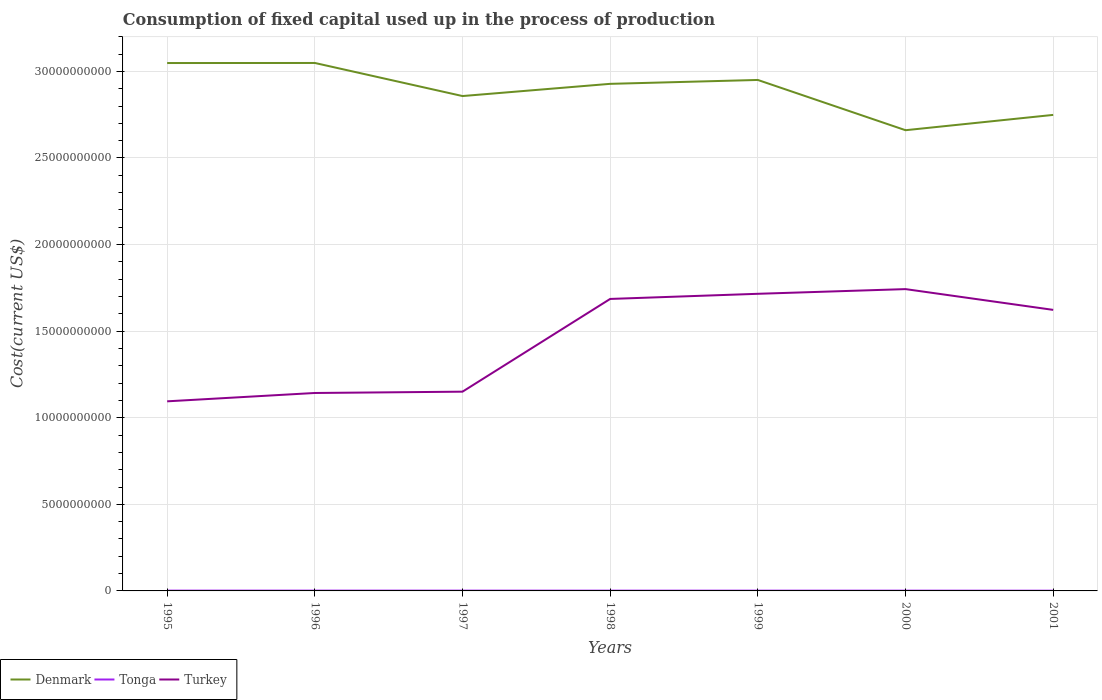How many different coloured lines are there?
Your answer should be compact. 3. Across all years, what is the maximum amount consumed in the process of production in Turkey?
Your answer should be very brief. 1.09e+1. In which year was the amount consumed in the process of production in Tonga maximum?
Offer a terse response. 2001. What is the total amount consumed in the process of production in Turkey in the graph?
Offer a terse response. -6.00e+09. What is the difference between the highest and the second highest amount consumed in the process of production in Denmark?
Your response must be concise. 3.88e+09. What is the difference between the highest and the lowest amount consumed in the process of production in Turkey?
Offer a very short reply. 4. How many years are there in the graph?
Your answer should be very brief. 7. Are the values on the major ticks of Y-axis written in scientific E-notation?
Your answer should be compact. No. Does the graph contain grids?
Provide a short and direct response. Yes. Where does the legend appear in the graph?
Your answer should be compact. Bottom left. How many legend labels are there?
Offer a terse response. 3. How are the legend labels stacked?
Ensure brevity in your answer.  Horizontal. What is the title of the graph?
Offer a terse response. Consumption of fixed capital used up in the process of production. Does "Togo" appear as one of the legend labels in the graph?
Your answer should be compact. No. What is the label or title of the Y-axis?
Ensure brevity in your answer.  Cost(current US$). What is the Cost(current US$) in Denmark in 1995?
Keep it short and to the point. 3.05e+1. What is the Cost(current US$) of Tonga in 1995?
Offer a very short reply. 1.70e+07. What is the Cost(current US$) in Turkey in 1995?
Offer a very short reply. 1.09e+1. What is the Cost(current US$) in Denmark in 1996?
Your response must be concise. 3.05e+1. What is the Cost(current US$) in Tonga in 1996?
Keep it short and to the point. 1.83e+07. What is the Cost(current US$) in Turkey in 1996?
Provide a succinct answer. 1.14e+1. What is the Cost(current US$) of Denmark in 1997?
Your answer should be very brief. 2.86e+1. What is the Cost(current US$) of Tonga in 1997?
Offer a very short reply. 1.72e+07. What is the Cost(current US$) in Turkey in 1997?
Give a very brief answer. 1.15e+1. What is the Cost(current US$) in Denmark in 1998?
Offer a terse response. 2.93e+1. What is the Cost(current US$) of Tonga in 1998?
Offer a terse response. 1.61e+07. What is the Cost(current US$) in Turkey in 1998?
Provide a short and direct response. 1.69e+1. What is the Cost(current US$) in Denmark in 1999?
Offer a very short reply. 2.95e+1. What is the Cost(current US$) in Tonga in 1999?
Your answer should be compact. 1.65e+07. What is the Cost(current US$) in Turkey in 1999?
Offer a terse response. 1.72e+1. What is the Cost(current US$) of Denmark in 2000?
Offer a very short reply. 2.66e+1. What is the Cost(current US$) in Tonga in 2000?
Your answer should be compact. 1.59e+07. What is the Cost(current US$) of Turkey in 2000?
Offer a very short reply. 1.74e+1. What is the Cost(current US$) of Denmark in 2001?
Make the answer very short. 2.75e+1. What is the Cost(current US$) of Tonga in 2001?
Offer a terse response. 1.39e+07. What is the Cost(current US$) of Turkey in 2001?
Keep it short and to the point. 1.62e+1. Across all years, what is the maximum Cost(current US$) of Denmark?
Give a very brief answer. 3.05e+1. Across all years, what is the maximum Cost(current US$) in Tonga?
Make the answer very short. 1.83e+07. Across all years, what is the maximum Cost(current US$) in Turkey?
Keep it short and to the point. 1.74e+1. Across all years, what is the minimum Cost(current US$) in Denmark?
Provide a succinct answer. 2.66e+1. Across all years, what is the minimum Cost(current US$) of Tonga?
Your answer should be very brief. 1.39e+07. Across all years, what is the minimum Cost(current US$) in Turkey?
Provide a succinct answer. 1.09e+1. What is the total Cost(current US$) of Denmark in the graph?
Provide a short and direct response. 2.02e+11. What is the total Cost(current US$) in Tonga in the graph?
Keep it short and to the point. 1.15e+08. What is the total Cost(current US$) of Turkey in the graph?
Ensure brevity in your answer.  1.02e+11. What is the difference between the Cost(current US$) of Denmark in 1995 and that in 1996?
Make the answer very short. -4.43e+06. What is the difference between the Cost(current US$) of Tonga in 1995 and that in 1996?
Make the answer very short. -1.26e+06. What is the difference between the Cost(current US$) in Turkey in 1995 and that in 1996?
Your response must be concise. -4.82e+08. What is the difference between the Cost(current US$) in Denmark in 1995 and that in 1997?
Keep it short and to the point. 1.91e+09. What is the difference between the Cost(current US$) of Tonga in 1995 and that in 1997?
Provide a short and direct response. -1.65e+05. What is the difference between the Cost(current US$) in Turkey in 1995 and that in 1997?
Offer a terse response. -5.57e+08. What is the difference between the Cost(current US$) in Denmark in 1995 and that in 1998?
Your answer should be compact. 1.20e+09. What is the difference between the Cost(current US$) in Tonga in 1995 and that in 1998?
Offer a terse response. 9.78e+05. What is the difference between the Cost(current US$) in Turkey in 1995 and that in 1998?
Keep it short and to the point. -5.91e+09. What is the difference between the Cost(current US$) in Denmark in 1995 and that in 1999?
Make the answer very short. 9.77e+08. What is the difference between the Cost(current US$) in Tonga in 1995 and that in 1999?
Ensure brevity in your answer.  5.65e+05. What is the difference between the Cost(current US$) in Turkey in 1995 and that in 1999?
Make the answer very short. -6.21e+09. What is the difference between the Cost(current US$) in Denmark in 1995 and that in 2000?
Your response must be concise. 3.88e+09. What is the difference between the Cost(current US$) of Tonga in 1995 and that in 2000?
Your answer should be very brief. 1.09e+06. What is the difference between the Cost(current US$) of Turkey in 1995 and that in 2000?
Your response must be concise. -6.48e+09. What is the difference between the Cost(current US$) in Denmark in 1995 and that in 2001?
Give a very brief answer. 2.99e+09. What is the difference between the Cost(current US$) of Tonga in 1995 and that in 2001?
Your answer should be compact. 3.12e+06. What is the difference between the Cost(current US$) in Turkey in 1995 and that in 2001?
Give a very brief answer. -5.28e+09. What is the difference between the Cost(current US$) of Denmark in 1996 and that in 1997?
Keep it short and to the point. 1.91e+09. What is the difference between the Cost(current US$) in Tonga in 1996 and that in 1997?
Your response must be concise. 1.10e+06. What is the difference between the Cost(current US$) of Turkey in 1996 and that in 1997?
Keep it short and to the point. -7.52e+07. What is the difference between the Cost(current US$) of Denmark in 1996 and that in 1998?
Provide a short and direct response. 1.21e+09. What is the difference between the Cost(current US$) of Tonga in 1996 and that in 1998?
Your answer should be very brief. 2.24e+06. What is the difference between the Cost(current US$) in Turkey in 1996 and that in 1998?
Your response must be concise. -5.43e+09. What is the difference between the Cost(current US$) in Denmark in 1996 and that in 1999?
Your answer should be very brief. 9.82e+08. What is the difference between the Cost(current US$) in Tonga in 1996 and that in 1999?
Keep it short and to the point. 1.83e+06. What is the difference between the Cost(current US$) of Turkey in 1996 and that in 1999?
Keep it short and to the point. -5.73e+09. What is the difference between the Cost(current US$) in Denmark in 1996 and that in 2000?
Provide a succinct answer. 3.88e+09. What is the difference between the Cost(current US$) of Tonga in 1996 and that in 2000?
Your answer should be compact. 2.35e+06. What is the difference between the Cost(current US$) in Turkey in 1996 and that in 2000?
Offer a very short reply. -6.00e+09. What is the difference between the Cost(current US$) in Denmark in 1996 and that in 2001?
Keep it short and to the point. 3.00e+09. What is the difference between the Cost(current US$) of Tonga in 1996 and that in 2001?
Make the answer very short. 4.38e+06. What is the difference between the Cost(current US$) in Turkey in 1996 and that in 2001?
Provide a short and direct response. -4.80e+09. What is the difference between the Cost(current US$) in Denmark in 1997 and that in 1998?
Offer a terse response. -7.05e+08. What is the difference between the Cost(current US$) in Tonga in 1997 and that in 1998?
Provide a short and direct response. 1.14e+06. What is the difference between the Cost(current US$) of Turkey in 1997 and that in 1998?
Give a very brief answer. -5.36e+09. What is the difference between the Cost(current US$) of Denmark in 1997 and that in 1999?
Ensure brevity in your answer.  -9.29e+08. What is the difference between the Cost(current US$) of Tonga in 1997 and that in 1999?
Provide a succinct answer. 7.30e+05. What is the difference between the Cost(current US$) of Turkey in 1997 and that in 1999?
Keep it short and to the point. -5.65e+09. What is the difference between the Cost(current US$) of Denmark in 1997 and that in 2000?
Give a very brief answer. 1.97e+09. What is the difference between the Cost(current US$) in Tonga in 1997 and that in 2000?
Provide a short and direct response. 1.25e+06. What is the difference between the Cost(current US$) of Turkey in 1997 and that in 2000?
Offer a very short reply. -5.92e+09. What is the difference between the Cost(current US$) in Denmark in 1997 and that in 2001?
Provide a succinct answer. 1.09e+09. What is the difference between the Cost(current US$) in Tonga in 1997 and that in 2001?
Your answer should be very brief. 3.28e+06. What is the difference between the Cost(current US$) of Turkey in 1997 and that in 2001?
Make the answer very short. -4.72e+09. What is the difference between the Cost(current US$) in Denmark in 1998 and that in 1999?
Keep it short and to the point. -2.24e+08. What is the difference between the Cost(current US$) in Tonga in 1998 and that in 1999?
Your response must be concise. -4.14e+05. What is the difference between the Cost(current US$) in Turkey in 1998 and that in 1999?
Make the answer very short. -2.97e+08. What is the difference between the Cost(current US$) in Denmark in 1998 and that in 2000?
Offer a very short reply. 2.68e+09. What is the difference between the Cost(current US$) of Tonga in 1998 and that in 2000?
Provide a succinct answer. 1.09e+05. What is the difference between the Cost(current US$) in Turkey in 1998 and that in 2000?
Give a very brief answer. -5.67e+08. What is the difference between the Cost(current US$) in Denmark in 1998 and that in 2001?
Offer a very short reply. 1.79e+09. What is the difference between the Cost(current US$) of Tonga in 1998 and that in 2001?
Your answer should be compact. 2.14e+06. What is the difference between the Cost(current US$) of Turkey in 1998 and that in 2001?
Make the answer very short. 6.33e+08. What is the difference between the Cost(current US$) of Denmark in 1999 and that in 2000?
Offer a very short reply. 2.90e+09. What is the difference between the Cost(current US$) in Tonga in 1999 and that in 2000?
Your answer should be compact. 5.22e+05. What is the difference between the Cost(current US$) of Turkey in 1999 and that in 2000?
Make the answer very short. -2.71e+08. What is the difference between the Cost(current US$) of Denmark in 1999 and that in 2001?
Your response must be concise. 2.02e+09. What is the difference between the Cost(current US$) of Tonga in 1999 and that in 2001?
Offer a very short reply. 2.55e+06. What is the difference between the Cost(current US$) of Turkey in 1999 and that in 2001?
Provide a succinct answer. 9.29e+08. What is the difference between the Cost(current US$) in Denmark in 2000 and that in 2001?
Your answer should be compact. -8.84e+08. What is the difference between the Cost(current US$) of Tonga in 2000 and that in 2001?
Provide a succinct answer. 2.03e+06. What is the difference between the Cost(current US$) in Turkey in 2000 and that in 2001?
Give a very brief answer. 1.20e+09. What is the difference between the Cost(current US$) in Denmark in 1995 and the Cost(current US$) in Tonga in 1996?
Provide a short and direct response. 3.05e+1. What is the difference between the Cost(current US$) of Denmark in 1995 and the Cost(current US$) of Turkey in 1996?
Offer a very short reply. 1.91e+1. What is the difference between the Cost(current US$) in Tonga in 1995 and the Cost(current US$) in Turkey in 1996?
Your answer should be compact. -1.14e+1. What is the difference between the Cost(current US$) of Denmark in 1995 and the Cost(current US$) of Tonga in 1997?
Make the answer very short. 3.05e+1. What is the difference between the Cost(current US$) in Denmark in 1995 and the Cost(current US$) in Turkey in 1997?
Make the answer very short. 1.90e+1. What is the difference between the Cost(current US$) in Tonga in 1995 and the Cost(current US$) in Turkey in 1997?
Your answer should be compact. -1.15e+1. What is the difference between the Cost(current US$) of Denmark in 1995 and the Cost(current US$) of Tonga in 1998?
Your answer should be very brief. 3.05e+1. What is the difference between the Cost(current US$) of Denmark in 1995 and the Cost(current US$) of Turkey in 1998?
Your answer should be compact. 1.36e+1. What is the difference between the Cost(current US$) in Tonga in 1995 and the Cost(current US$) in Turkey in 1998?
Provide a succinct answer. -1.68e+1. What is the difference between the Cost(current US$) in Denmark in 1995 and the Cost(current US$) in Tonga in 1999?
Offer a terse response. 3.05e+1. What is the difference between the Cost(current US$) of Denmark in 1995 and the Cost(current US$) of Turkey in 1999?
Offer a terse response. 1.33e+1. What is the difference between the Cost(current US$) of Tonga in 1995 and the Cost(current US$) of Turkey in 1999?
Keep it short and to the point. -1.71e+1. What is the difference between the Cost(current US$) in Denmark in 1995 and the Cost(current US$) in Tonga in 2000?
Keep it short and to the point. 3.05e+1. What is the difference between the Cost(current US$) of Denmark in 1995 and the Cost(current US$) of Turkey in 2000?
Provide a short and direct response. 1.31e+1. What is the difference between the Cost(current US$) of Tonga in 1995 and the Cost(current US$) of Turkey in 2000?
Provide a short and direct response. -1.74e+1. What is the difference between the Cost(current US$) of Denmark in 1995 and the Cost(current US$) of Tonga in 2001?
Provide a succinct answer. 3.05e+1. What is the difference between the Cost(current US$) in Denmark in 1995 and the Cost(current US$) in Turkey in 2001?
Provide a short and direct response. 1.43e+1. What is the difference between the Cost(current US$) in Tonga in 1995 and the Cost(current US$) in Turkey in 2001?
Offer a very short reply. -1.62e+1. What is the difference between the Cost(current US$) of Denmark in 1996 and the Cost(current US$) of Tonga in 1997?
Your response must be concise. 3.05e+1. What is the difference between the Cost(current US$) in Denmark in 1996 and the Cost(current US$) in Turkey in 1997?
Your response must be concise. 1.90e+1. What is the difference between the Cost(current US$) in Tonga in 1996 and the Cost(current US$) in Turkey in 1997?
Offer a terse response. -1.15e+1. What is the difference between the Cost(current US$) of Denmark in 1996 and the Cost(current US$) of Tonga in 1998?
Provide a short and direct response. 3.05e+1. What is the difference between the Cost(current US$) of Denmark in 1996 and the Cost(current US$) of Turkey in 1998?
Keep it short and to the point. 1.36e+1. What is the difference between the Cost(current US$) of Tonga in 1996 and the Cost(current US$) of Turkey in 1998?
Your response must be concise. -1.68e+1. What is the difference between the Cost(current US$) of Denmark in 1996 and the Cost(current US$) of Tonga in 1999?
Provide a short and direct response. 3.05e+1. What is the difference between the Cost(current US$) in Denmark in 1996 and the Cost(current US$) in Turkey in 1999?
Give a very brief answer. 1.33e+1. What is the difference between the Cost(current US$) in Tonga in 1996 and the Cost(current US$) in Turkey in 1999?
Ensure brevity in your answer.  -1.71e+1. What is the difference between the Cost(current US$) of Denmark in 1996 and the Cost(current US$) of Tonga in 2000?
Make the answer very short. 3.05e+1. What is the difference between the Cost(current US$) in Denmark in 1996 and the Cost(current US$) in Turkey in 2000?
Make the answer very short. 1.31e+1. What is the difference between the Cost(current US$) in Tonga in 1996 and the Cost(current US$) in Turkey in 2000?
Keep it short and to the point. -1.74e+1. What is the difference between the Cost(current US$) in Denmark in 1996 and the Cost(current US$) in Tonga in 2001?
Provide a succinct answer. 3.05e+1. What is the difference between the Cost(current US$) in Denmark in 1996 and the Cost(current US$) in Turkey in 2001?
Your answer should be compact. 1.43e+1. What is the difference between the Cost(current US$) in Tonga in 1996 and the Cost(current US$) in Turkey in 2001?
Offer a terse response. -1.62e+1. What is the difference between the Cost(current US$) of Denmark in 1997 and the Cost(current US$) of Tonga in 1998?
Offer a very short reply. 2.86e+1. What is the difference between the Cost(current US$) in Denmark in 1997 and the Cost(current US$) in Turkey in 1998?
Provide a short and direct response. 1.17e+1. What is the difference between the Cost(current US$) in Tonga in 1997 and the Cost(current US$) in Turkey in 1998?
Provide a short and direct response. -1.68e+1. What is the difference between the Cost(current US$) in Denmark in 1997 and the Cost(current US$) in Tonga in 1999?
Offer a terse response. 2.86e+1. What is the difference between the Cost(current US$) in Denmark in 1997 and the Cost(current US$) in Turkey in 1999?
Your answer should be very brief. 1.14e+1. What is the difference between the Cost(current US$) of Tonga in 1997 and the Cost(current US$) of Turkey in 1999?
Offer a terse response. -1.71e+1. What is the difference between the Cost(current US$) of Denmark in 1997 and the Cost(current US$) of Tonga in 2000?
Provide a short and direct response. 2.86e+1. What is the difference between the Cost(current US$) in Denmark in 1997 and the Cost(current US$) in Turkey in 2000?
Your answer should be compact. 1.11e+1. What is the difference between the Cost(current US$) in Tonga in 1997 and the Cost(current US$) in Turkey in 2000?
Your answer should be compact. -1.74e+1. What is the difference between the Cost(current US$) in Denmark in 1997 and the Cost(current US$) in Tonga in 2001?
Make the answer very short. 2.86e+1. What is the difference between the Cost(current US$) in Denmark in 1997 and the Cost(current US$) in Turkey in 2001?
Keep it short and to the point. 1.23e+1. What is the difference between the Cost(current US$) in Tonga in 1997 and the Cost(current US$) in Turkey in 2001?
Your answer should be compact. -1.62e+1. What is the difference between the Cost(current US$) in Denmark in 1998 and the Cost(current US$) in Tonga in 1999?
Offer a terse response. 2.93e+1. What is the difference between the Cost(current US$) of Denmark in 1998 and the Cost(current US$) of Turkey in 1999?
Your answer should be very brief. 1.21e+1. What is the difference between the Cost(current US$) of Tonga in 1998 and the Cost(current US$) of Turkey in 1999?
Give a very brief answer. -1.71e+1. What is the difference between the Cost(current US$) in Denmark in 1998 and the Cost(current US$) in Tonga in 2000?
Your answer should be compact. 2.93e+1. What is the difference between the Cost(current US$) of Denmark in 1998 and the Cost(current US$) of Turkey in 2000?
Keep it short and to the point. 1.19e+1. What is the difference between the Cost(current US$) of Tonga in 1998 and the Cost(current US$) of Turkey in 2000?
Your answer should be compact. -1.74e+1. What is the difference between the Cost(current US$) of Denmark in 1998 and the Cost(current US$) of Tonga in 2001?
Keep it short and to the point. 2.93e+1. What is the difference between the Cost(current US$) of Denmark in 1998 and the Cost(current US$) of Turkey in 2001?
Ensure brevity in your answer.  1.31e+1. What is the difference between the Cost(current US$) of Tonga in 1998 and the Cost(current US$) of Turkey in 2001?
Your response must be concise. -1.62e+1. What is the difference between the Cost(current US$) of Denmark in 1999 and the Cost(current US$) of Tonga in 2000?
Make the answer very short. 2.95e+1. What is the difference between the Cost(current US$) of Denmark in 1999 and the Cost(current US$) of Turkey in 2000?
Your answer should be very brief. 1.21e+1. What is the difference between the Cost(current US$) in Tonga in 1999 and the Cost(current US$) in Turkey in 2000?
Give a very brief answer. -1.74e+1. What is the difference between the Cost(current US$) in Denmark in 1999 and the Cost(current US$) in Tonga in 2001?
Offer a terse response. 2.95e+1. What is the difference between the Cost(current US$) in Denmark in 1999 and the Cost(current US$) in Turkey in 2001?
Ensure brevity in your answer.  1.33e+1. What is the difference between the Cost(current US$) of Tonga in 1999 and the Cost(current US$) of Turkey in 2001?
Your response must be concise. -1.62e+1. What is the difference between the Cost(current US$) in Denmark in 2000 and the Cost(current US$) in Tonga in 2001?
Provide a succinct answer. 2.66e+1. What is the difference between the Cost(current US$) of Denmark in 2000 and the Cost(current US$) of Turkey in 2001?
Make the answer very short. 1.04e+1. What is the difference between the Cost(current US$) of Tonga in 2000 and the Cost(current US$) of Turkey in 2001?
Offer a terse response. -1.62e+1. What is the average Cost(current US$) of Denmark per year?
Your answer should be compact. 2.89e+1. What is the average Cost(current US$) of Tonga per year?
Provide a succinct answer. 1.64e+07. What is the average Cost(current US$) in Turkey per year?
Keep it short and to the point. 1.45e+1. In the year 1995, what is the difference between the Cost(current US$) in Denmark and Cost(current US$) in Tonga?
Keep it short and to the point. 3.05e+1. In the year 1995, what is the difference between the Cost(current US$) in Denmark and Cost(current US$) in Turkey?
Your response must be concise. 1.95e+1. In the year 1995, what is the difference between the Cost(current US$) of Tonga and Cost(current US$) of Turkey?
Offer a terse response. -1.09e+1. In the year 1996, what is the difference between the Cost(current US$) of Denmark and Cost(current US$) of Tonga?
Ensure brevity in your answer.  3.05e+1. In the year 1996, what is the difference between the Cost(current US$) in Denmark and Cost(current US$) in Turkey?
Offer a terse response. 1.91e+1. In the year 1996, what is the difference between the Cost(current US$) of Tonga and Cost(current US$) of Turkey?
Give a very brief answer. -1.14e+1. In the year 1997, what is the difference between the Cost(current US$) of Denmark and Cost(current US$) of Tonga?
Provide a succinct answer. 2.86e+1. In the year 1997, what is the difference between the Cost(current US$) in Denmark and Cost(current US$) in Turkey?
Your response must be concise. 1.71e+1. In the year 1997, what is the difference between the Cost(current US$) in Tonga and Cost(current US$) in Turkey?
Offer a very short reply. -1.15e+1. In the year 1998, what is the difference between the Cost(current US$) in Denmark and Cost(current US$) in Tonga?
Ensure brevity in your answer.  2.93e+1. In the year 1998, what is the difference between the Cost(current US$) of Denmark and Cost(current US$) of Turkey?
Offer a terse response. 1.24e+1. In the year 1998, what is the difference between the Cost(current US$) of Tonga and Cost(current US$) of Turkey?
Provide a short and direct response. -1.68e+1. In the year 1999, what is the difference between the Cost(current US$) of Denmark and Cost(current US$) of Tonga?
Give a very brief answer. 2.95e+1. In the year 1999, what is the difference between the Cost(current US$) of Denmark and Cost(current US$) of Turkey?
Ensure brevity in your answer.  1.23e+1. In the year 1999, what is the difference between the Cost(current US$) in Tonga and Cost(current US$) in Turkey?
Make the answer very short. -1.71e+1. In the year 2000, what is the difference between the Cost(current US$) in Denmark and Cost(current US$) in Tonga?
Provide a succinct answer. 2.66e+1. In the year 2000, what is the difference between the Cost(current US$) in Denmark and Cost(current US$) in Turkey?
Provide a short and direct response. 9.18e+09. In the year 2000, what is the difference between the Cost(current US$) in Tonga and Cost(current US$) in Turkey?
Offer a very short reply. -1.74e+1. In the year 2001, what is the difference between the Cost(current US$) in Denmark and Cost(current US$) in Tonga?
Keep it short and to the point. 2.75e+1. In the year 2001, what is the difference between the Cost(current US$) in Denmark and Cost(current US$) in Turkey?
Provide a short and direct response. 1.13e+1. In the year 2001, what is the difference between the Cost(current US$) of Tonga and Cost(current US$) of Turkey?
Offer a very short reply. -1.62e+1. What is the ratio of the Cost(current US$) in Turkey in 1995 to that in 1996?
Provide a succinct answer. 0.96. What is the ratio of the Cost(current US$) in Denmark in 1995 to that in 1997?
Ensure brevity in your answer.  1.07. What is the ratio of the Cost(current US$) of Turkey in 1995 to that in 1997?
Your answer should be very brief. 0.95. What is the ratio of the Cost(current US$) of Denmark in 1995 to that in 1998?
Make the answer very short. 1.04. What is the ratio of the Cost(current US$) of Tonga in 1995 to that in 1998?
Make the answer very short. 1.06. What is the ratio of the Cost(current US$) in Turkey in 1995 to that in 1998?
Give a very brief answer. 0.65. What is the ratio of the Cost(current US$) of Denmark in 1995 to that in 1999?
Provide a succinct answer. 1.03. What is the ratio of the Cost(current US$) of Tonga in 1995 to that in 1999?
Your answer should be very brief. 1.03. What is the ratio of the Cost(current US$) in Turkey in 1995 to that in 1999?
Provide a short and direct response. 0.64. What is the ratio of the Cost(current US$) in Denmark in 1995 to that in 2000?
Make the answer very short. 1.15. What is the ratio of the Cost(current US$) of Tonga in 1995 to that in 2000?
Your answer should be very brief. 1.07. What is the ratio of the Cost(current US$) in Turkey in 1995 to that in 2000?
Your response must be concise. 0.63. What is the ratio of the Cost(current US$) of Denmark in 1995 to that in 2001?
Give a very brief answer. 1.11. What is the ratio of the Cost(current US$) in Tonga in 1995 to that in 2001?
Your answer should be very brief. 1.22. What is the ratio of the Cost(current US$) in Turkey in 1995 to that in 2001?
Offer a very short reply. 0.67. What is the ratio of the Cost(current US$) in Denmark in 1996 to that in 1997?
Your answer should be compact. 1.07. What is the ratio of the Cost(current US$) of Tonga in 1996 to that in 1997?
Offer a terse response. 1.06. What is the ratio of the Cost(current US$) in Turkey in 1996 to that in 1997?
Provide a short and direct response. 0.99. What is the ratio of the Cost(current US$) of Denmark in 1996 to that in 1998?
Make the answer very short. 1.04. What is the ratio of the Cost(current US$) of Tonga in 1996 to that in 1998?
Provide a short and direct response. 1.14. What is the ratio of the Cost(current US$) in Turkey in 1996 to that in 1998?
Make the answer very short. 0.68. What is the ratio of the Cost(current US$) in Denmark in 1996 to that in 1999?
Your answer should be compact. 1.03. What is the ratio of the Cost(current US$) of Tonga in 1996 to that in 1999?
Provide a succinct answer. 1.11. What is the ratio of the Cost(current US$) in Turkey in 1996 to that in 1999?
Your answer should be compact. 0.67. What is the ratio of the Cost(current US$) of Denmark in 1996 to that in 2000?
Give a very brief answer. 1.15. What is the ratio of the Cost(current US$) in Tonga in 1996 to that in 2000?
Your answer should be compact. 1.15. What is the ratio of the Cost(current US$) in Turkey in 1996 to that in 2000?
Your response must be concise. 0.66. What is the ratio of the Cost(current US$) of Denmark in 1996 to that in 2001?
Offer a very short reply. 1.11. What is the ratio of the Cost(current US$) in Tonga in 1996 to that in 2001?
Ensure brevity in your answer.  1.31. What is the ratio of the Cost(current US$) in Turkey in 1996 to that in 2001?
Your answer should be compact. 0.7. What is the ratio of the Cost(current US$) in Denmark in 1997 to that in 1998?
Your response must be concise. 0.98. What is the ratio of the Cost(current US$) in Tonga in 1997 to that in 1998?
Provide a short and direct response. 1.07. What is the ratio of the Cost(current US$) in Turkey in 1997 to that in 1998?
Keep it short and to the point. 0.68. What is the ratio of the Cost(current US$) of Denmark in 1997 to that in 1999?
Make the answer very short. 0.97. What is the ratio of the Cost(current US$) of Tonga in 1997 to that in 1999?
Your answer should be compact. 1.04. What is the ratio of the Cost(current US$) in Turkey in 1997 to that in 1999?
Give a very brief answer. 0.67. What is the ratio of the Cost(current US$) of Denmark in 1997 to that in 2000?
Provide a succinct answer. 1.07. What is the ratio of the Cost(current US$) in Tonga in 1997 to that in 2000?
Your answer should be very brief. 1.08. What is the ratio of the Cost(current US$) of Turkey in 1997 to that in 2000?
Offer a very short reply. 0.66. What is the ratio of the Cost(current US$) of Denmark in 1997 to that in 2001?
Offer a very short reply. 1.04. What is the ratio of the Cost(current US$) in Tonga in 1997 to that in 2001?
Your response must be concise. 1.24. What is the ratio of the Cost(current US$) of Turkey in 1997 to that in 2001?
Offer a terse response. 0.71. What is the ratio of the Cost(current US$) in Tonga in 1998 to that in 1999?
Make the answer very short. 0.97. What is the ratio of the Cost(current US$) in Turkey in 1998 to that in 1999?
Your answer should be very brief. 0.98. What is the ratio of the Cost(current US$) of Denmark in 1998 to that in 2000?
Offer a very short reply. 1.1. What is the ratio of the Cost(current US$) in Tonga in 1998 to that in 2000?
Ensure brevity in your answer.  1.01. What is the ratio of the Cost(current US$) in Turkey in 1998 to that in 2000?
Offer a terse response. 0.97. What is the ratio of the Cost(current US$) in Denmark in 1998 to that in 2001?
Your response must be concise. 1.07. What is the ratio of the Cost(current US$) in Tonga in 1998 to that in 2001?
Keep it short and to the point. 1.15. What is the ratio of the Cost(current US$) in Turkey in 1998 to that in 2001?
Give a very brief answer. 1.04. What is the ratio of the Cost(current US$) of Denmark in 1999 to that in 2000?
Provide a succinct answer. 1.11. What is the ratio of the Cost(current US$) in Tonga in 1999 to that in 2000?
Ensure brevity in your answer.  1.03. What is the ratio of the Cost(current US$) in Turkey in 1999 to that in 2000?
Keep it short and to the point. 0.98. What is the ratio of the Cost(current US$) of Denmark in 1999 to that in 2001?
Your answer should be very brief. 1.07. What is the ratio of the Cost(current US$) in Tonga in 1999 to that in 2001?
Offer a very short reply. 1.18. What is the ratio of the Cost(current US$) in Turkey in 1999 to that in 2001?
Your answer should be compact. 1.06. What is the ratio of the Cost(current US$) in Denmark in 2000 to that in 2001?
Offer a very short reply. 0.97. What is the ratio of the Cost(current US$) in Tonga in 2000 to that in 2001?
Give a very brief answer. 1.15. What is the ratio of the Cost(current US$) in Turkey in 2000 to that in 2001?
Offer a terse response. 1.07. What is the difference between the highest and the second highest Cost(current US$) of Denmark?
Your response must be concise. 4.43e+06. What is the difference between the highest and the second highest Cost(current US$) of Tonga?
Offer a very short reply. 1.10e+06. What is the difference between the highest and the second highest Cost(current US$) of Turkey?
Offer a terse response. 2.71e+08. What is the difference between the highest and the lowest Cost(current US$) in Denmark?
Provide a short and direct response. 3.88e+09. What is the difference between the highest and the lowest Cost(current US$) of Tonga?
Provide a short and direct response. 4.38e+06. What is the difference between the highest and the lowest Cost(current US$) in Turkey?
Make the answer very short. 6.48e+09. 